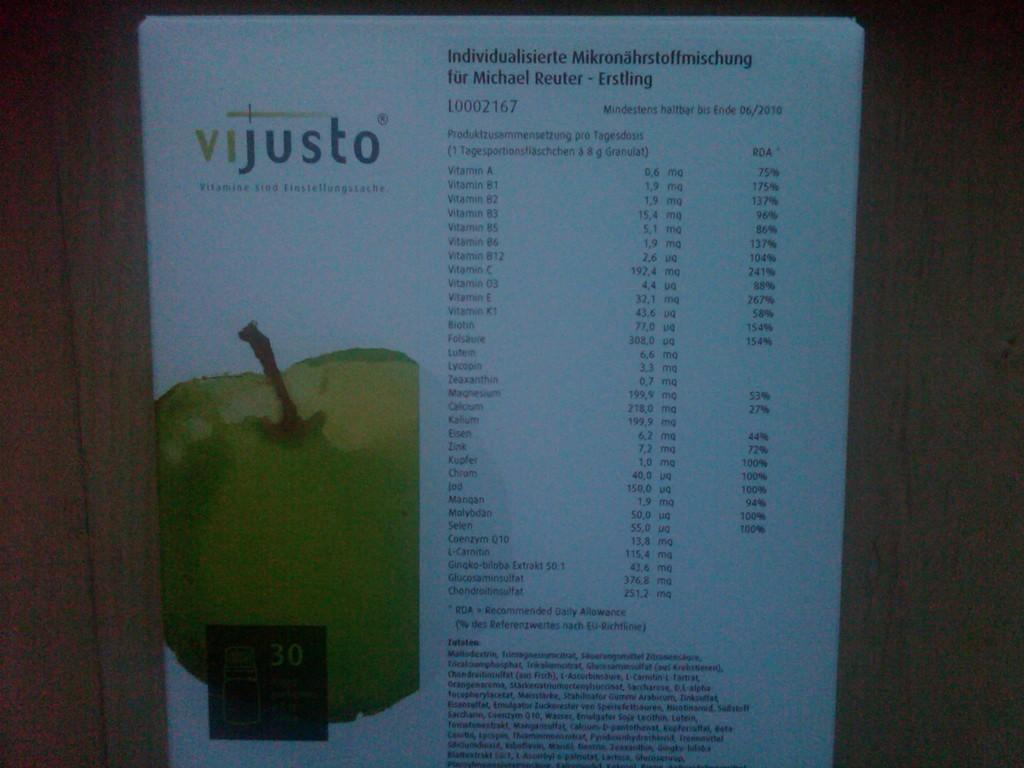<image>
Relay a brief, clear account of the picture shown. A Vijusto ad states the nutritional content of a product. 